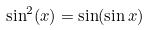Convert formula to latex. <formula><loc_0><loc_0><loc_500><loc_500>\sin ^ { 2 } ( x ) = \sin ( \sin x )</formula> 